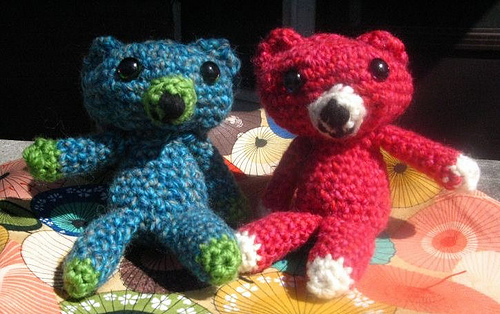<image>
Can you confirm if the teddybear is on the bed? Yes. Looking at the image, I can see the teddybear is positioned on top of the bed, with the bed providing support. Is there a blue bear behind the pink bear? No. The blue bear is not behind the pink bear. From this viewpoint, the blue bear appears to be positioned elsewhere in the scene. Where is the blue bear in relation to the red bear? Is it next to the red bear? Yes. The blue bear is positioned adjacent to the red bear, located nearby in the same general area. 